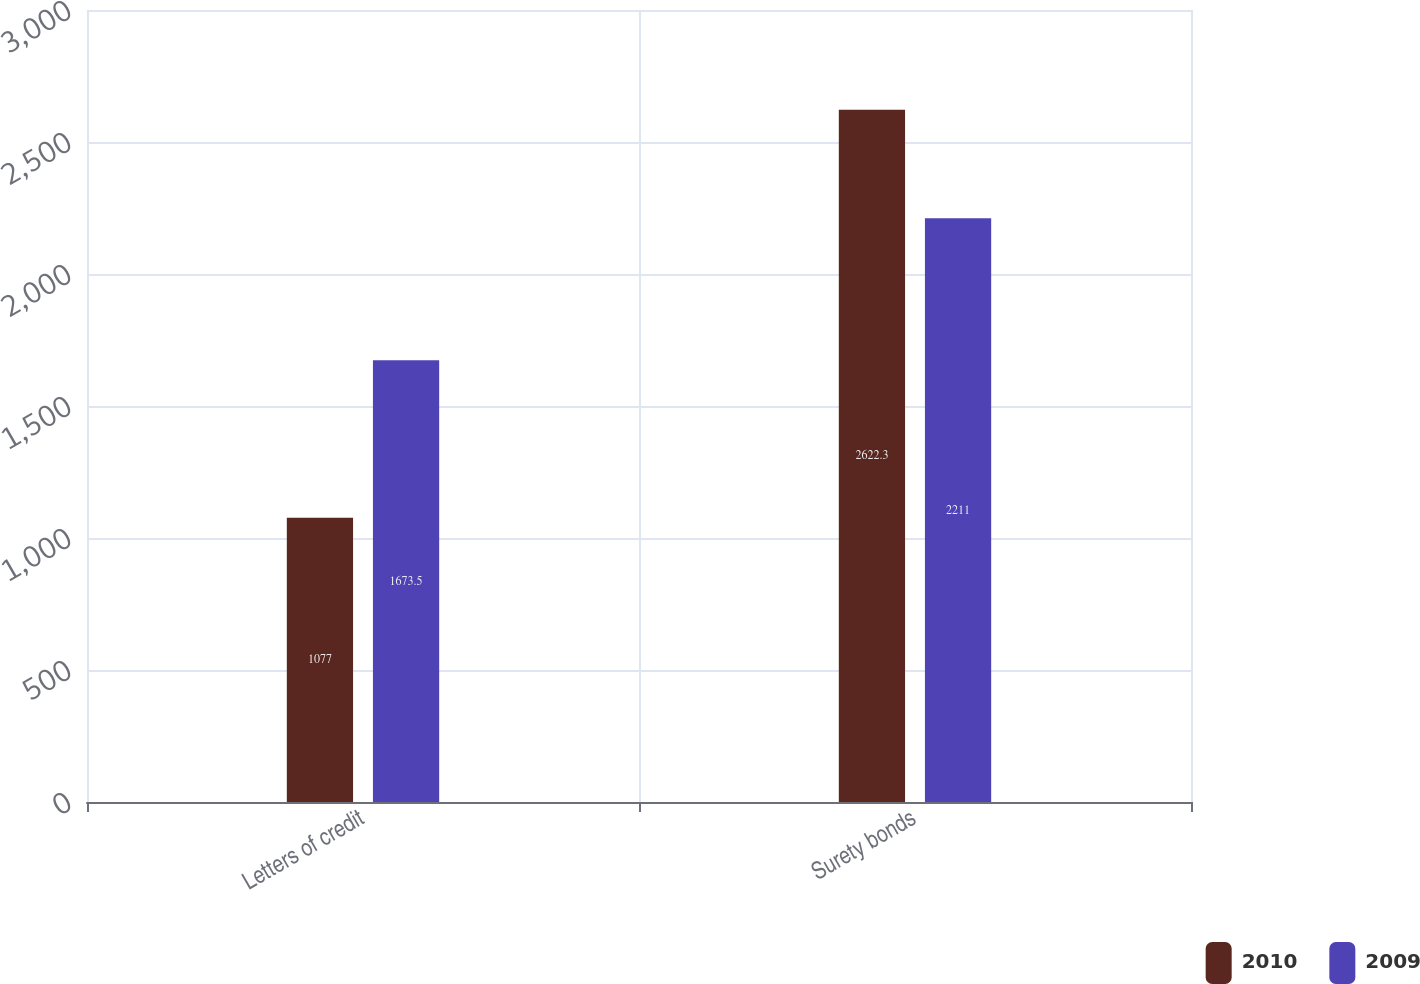Convert chart to OTSL. <chart><loc_0><loc_0><loc_500><loc_500><stacked_bar_chart><ecel><fcel>Letters of credit<fcel>Surety bonds<nl><fcel>2010<fcel>1077<fcel>2622.3<nl><fcel>2009<fcel>1673.5<fcel>2211<nl></chart> 